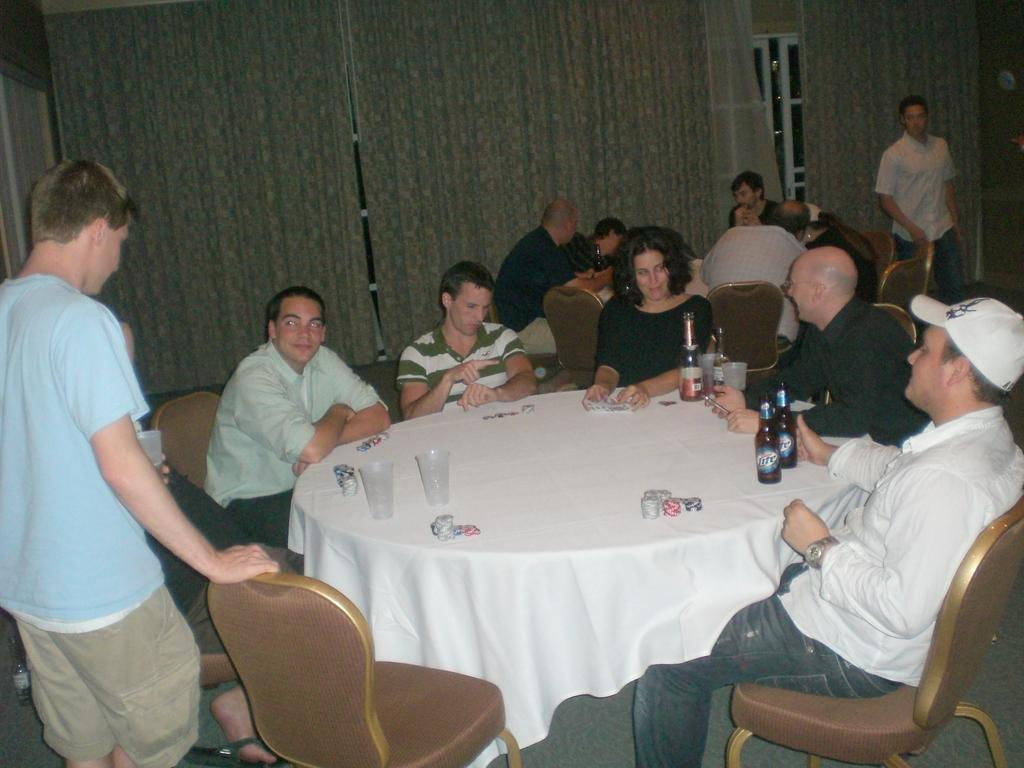How many people are in the image? There are people in the image, but the exact number is not specified. What are two people doing in the image? Two people are standing in the image. What are the other people doing in the image? The rest of the people are sitting on chairs in the image. What can be found on the table in the image? There are bottles and glasses on the table in the image. Can you see any goldfish swimming in the image? There are no goldfish present in the image. What does the person in the image feel regret about? There is no indication of any emotions or regrets in the image. 